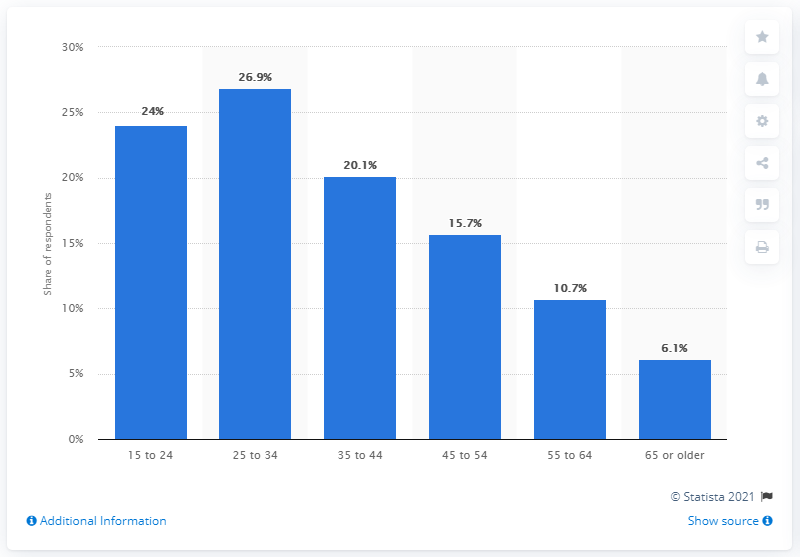Highlight a few significant elements in this photo. According to the survey, 6.1% of Canadians aged 65 and older reported consuming cannabis in the past three months. 